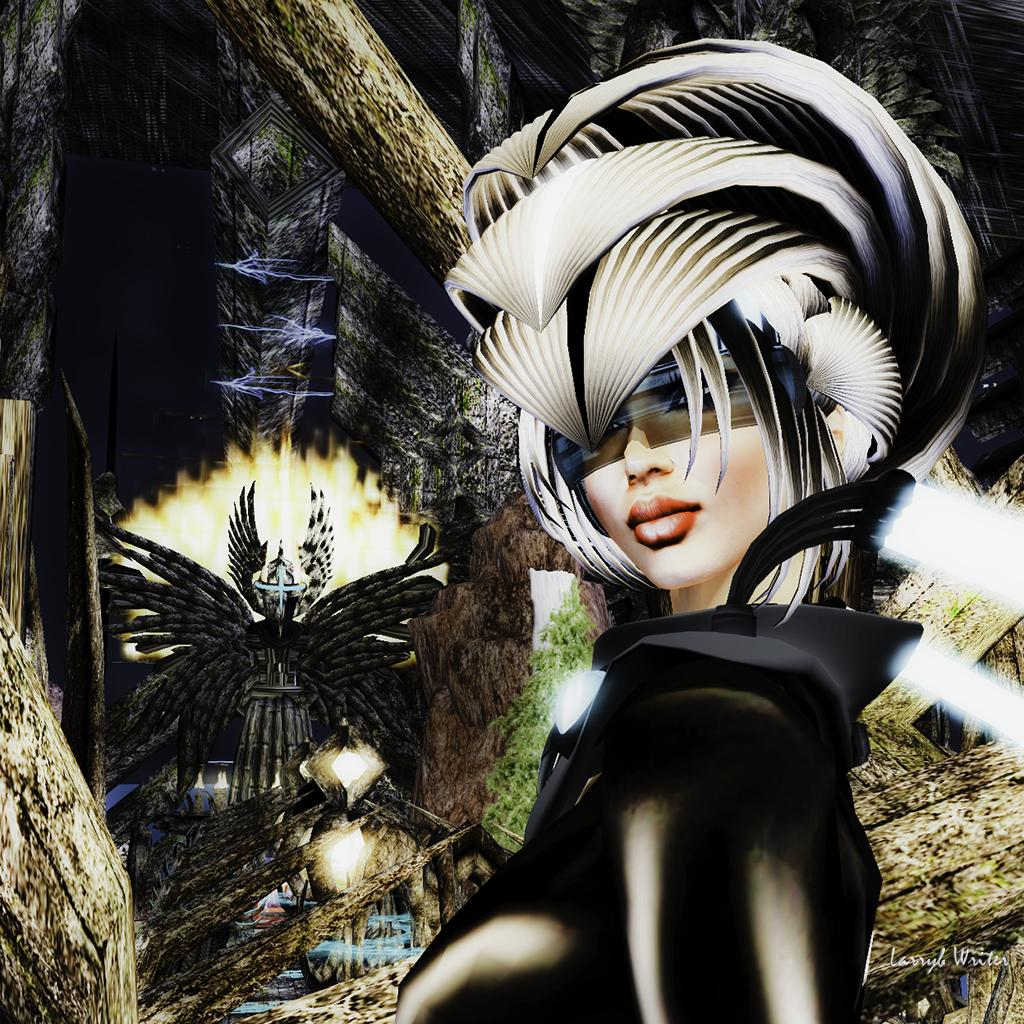What type of image is being described? The image is animated. Can you describe the person in the image? There is a person standing on the right side of the image. What can be seen in the background of the image? There are wooden objects and other unspecified objects in the background of the image. Can you tell me how many snails are crawling on the person in the image? There are no snails present in the image. What color is the egg that the person is holding in the image? There is no egg present in the image. 